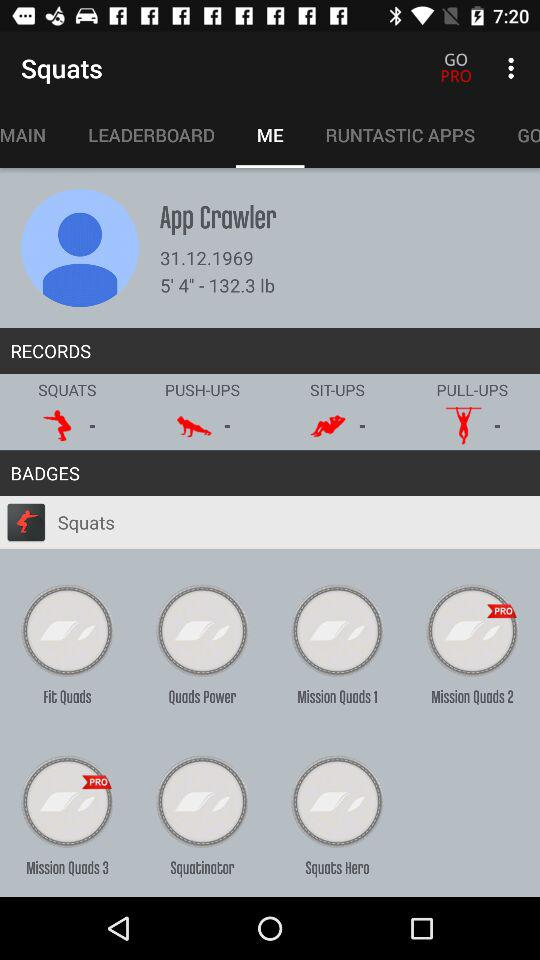What is the application name? The application name is "Squats". 